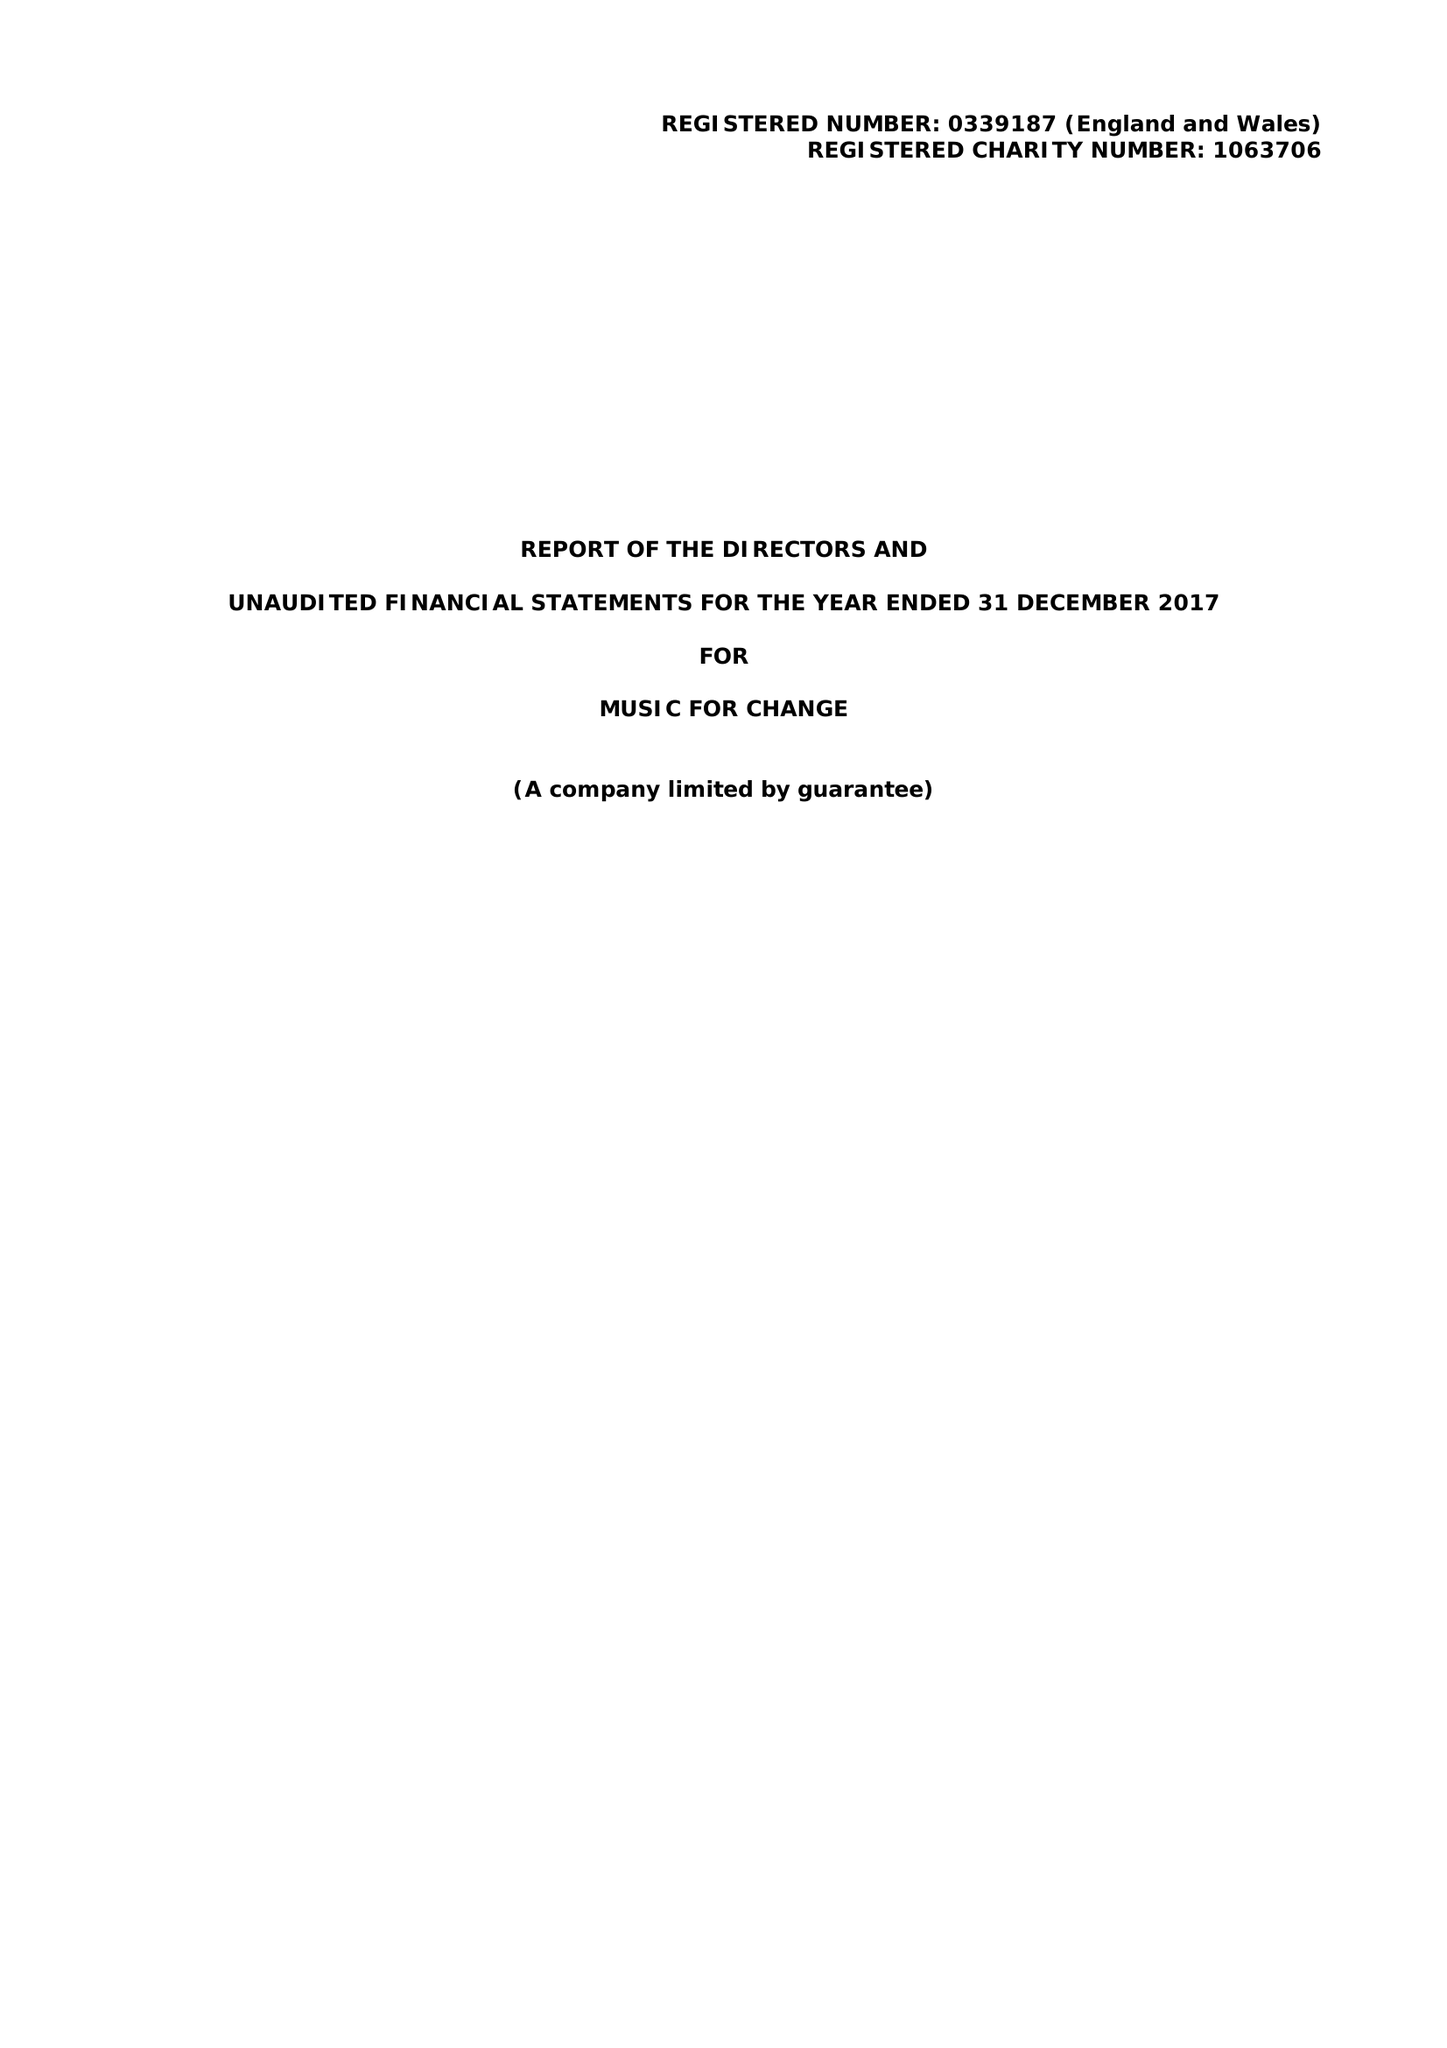What is the value for the address__street_line?
Answer the question using a single word or phrase. 77 STOUR STREET 